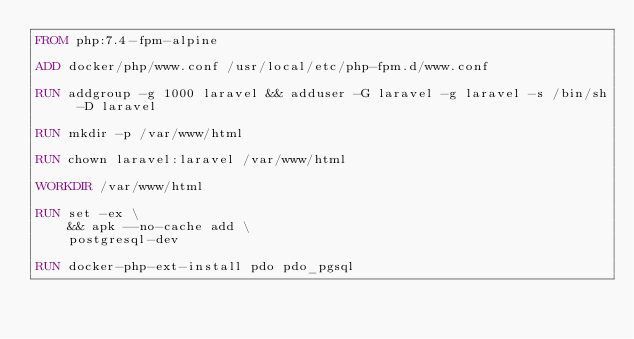<code> <loc_0><loc_0><loc_500><loc_500><_Dockerfile_>FROM php:7.4-fpm-alpine

ADD docker/php/www.conf /usr/local/etc/php-fpm.d/www.conf

RUN addgroup -g 1000 laravel && adduser -G laravel -g laravel -s /bin/sh -D laravel

RUN mkdir -p /var/www/html

RUN chown laravel:laravel /var/www/html

WORKDIR /var/www/html

RUN set -ex \
    && apk --no-cache add \
    postgresql-dev

RUN docker-php-ext-install pdo pdo_pgsql
</code> 